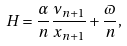Convert formula to latex. <formula><loc_0><loc_0><loc_500><loc_500>H = \frac { \alpha } { n } \frac { \nu _ { n + 1 } } { x _ { n + 1 } } + \frac { \varpi } { n } ,</formula> 